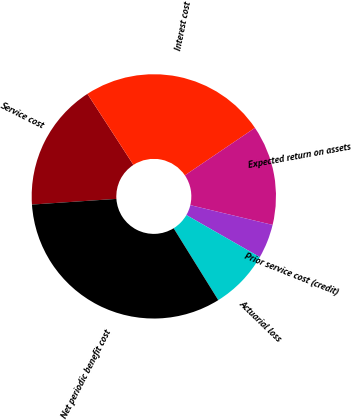<chart> <loc_0><loc_0><loc_500><loc_500><pie_chart><fcel>Service cost<fcel>Interest cost<fcel>Expected return on assets<fcel>Prior service cost (credit)<fcel>Actuarial loss<fcel>Net periodic benefit cost<nl><fcel>16.92%<fcel>24.67%<fcel>13.23%<fcel>4.53%<fcel>7.87%<fcel>32.78%<nl></chart> 